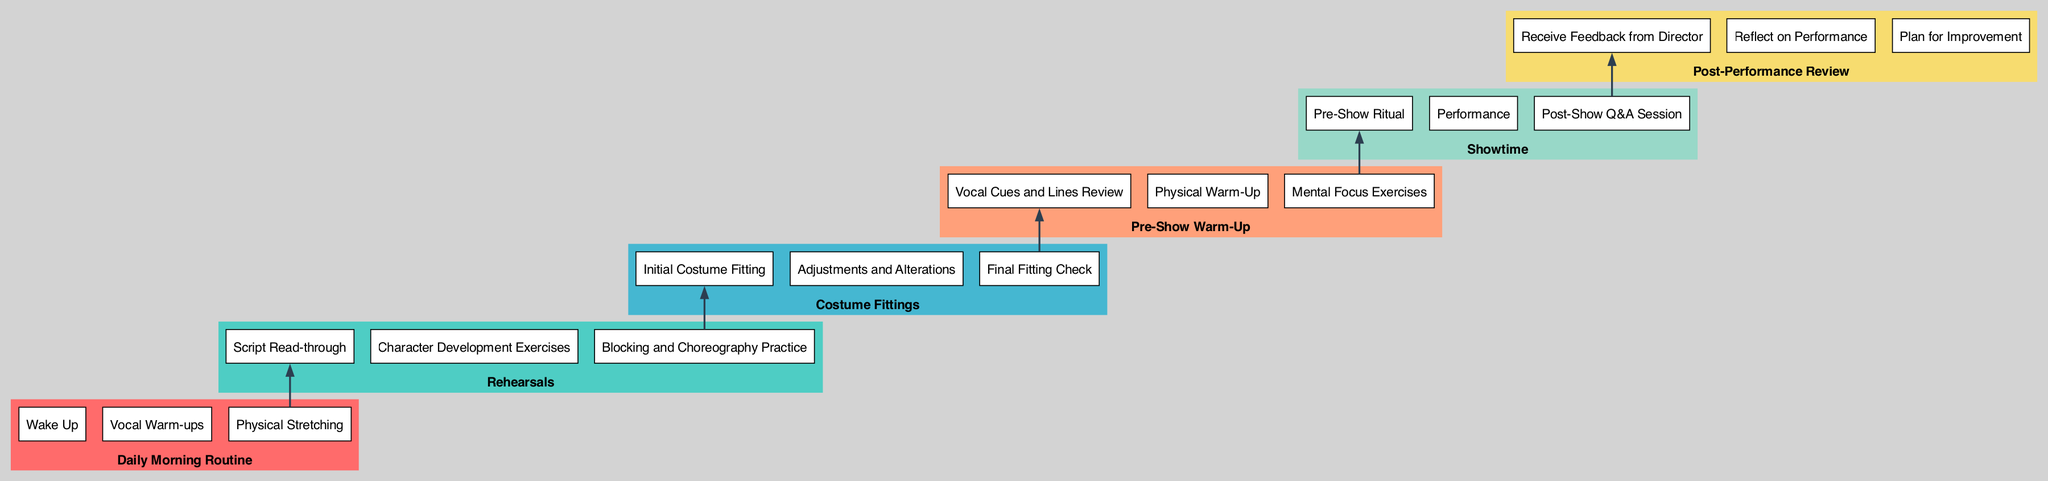What are the activities included in the 'Daily Morning Routine' node? The 'Daily Morning Routine' node has three activities listed: 'Wake Up', 'Vocal Warm-ups', and 'Physical Stretching'.
Answer: Wake Up, Vocal Warm-ups, Physical Stretching How many activities are there under the 'Costume Fittings' node? Under the 'Costume Fittings' node, there are three activities: 'Initial Costume Fitting', 'Adjustments and Alterations', and 'Final Fitting Check'. Counting these, the total is three.
Answer: 3 What is the first activity in the 'Showtime' node? The 'Showtime' node lists 'Pre-Show Ritual' as its first activity. It appears at the top of the node directly after the title.
Answer: Pre-Show Ritual Which node connects last to 'Post-Performance Review'? The last node before 'Post-Performance Review' is 'Showtime', as the edges visually connect them in the flow chart from the 'Showtime' node to the 'Post-Performance Review' node.
Answer: Showtime What is the second activity listed under 'Pre-Show Warm-Up'? The second activity in the 'Pre-Show Warm-Up' node is 'Physical Warm-Up', as it follows 'Vocal Cues and Lines Review' in the list.
Answer: Physical Warm-Up Which nodes do not have any incoming edges? The first node, 'Daily Morning Routine', does not have any incoming edges, as it is the starting point of the flow in this diagram structure.
Answer: Daily Morning Routine Which node represents the middle of the performance week? 'Rehearsals' is the middle node in terms of flow, as it appears after the 'Daily Morning Routine' and before 'Costume Fittings', connecting the beginning and end of the performance prep.
Answer: Rehearsals 